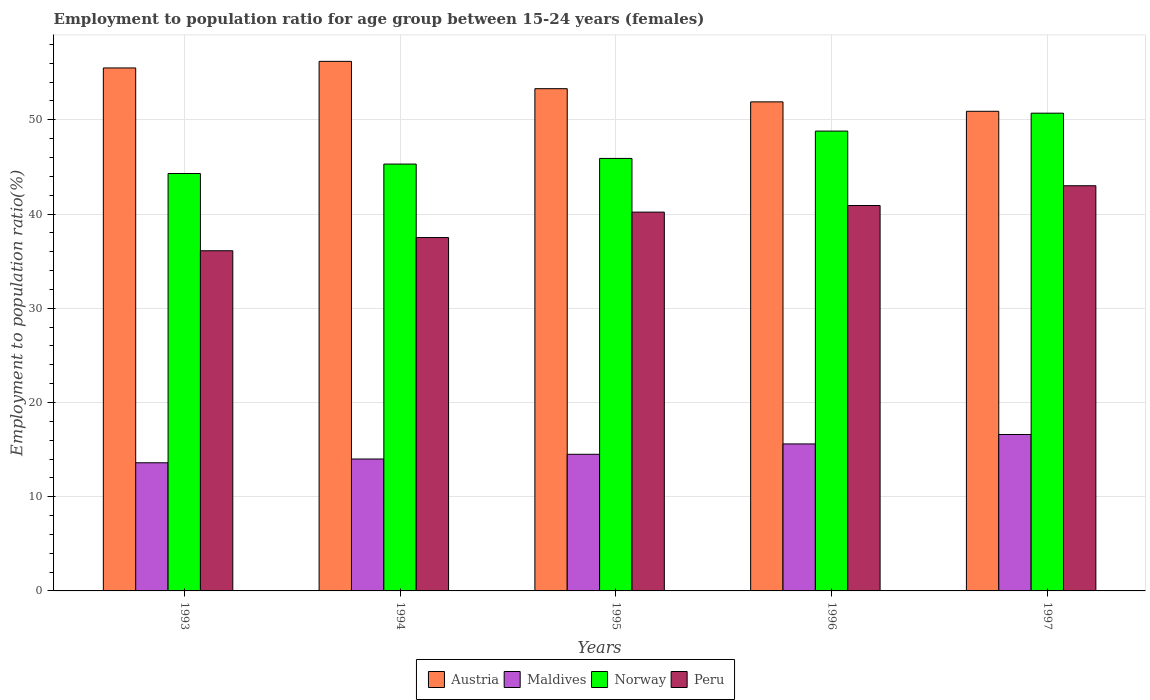Are the number of bars on each tick of the X-axis equal?
Ensure brevity in your answer.  Yes. How many bars are there on the 5th tick from the left?
Ensure brevity in your answer.  4. How many bars are there on the 1st tick from the right?
Offer a very short reply. 4. What is the label of the 2nd group of bars from the left?
Make the answer very short. 1994. In how many cases, is the number of bars for a given year not equal to the number of legend labels?
Your answer should be very brief. 0. What is the employment to population ratio in Maldives in 1996?
Provide a succinct answer. 15.6. Across all years, what is the maximum employment to population ratio in Austria?
Make the answer very short. 56.2. Across all years, what is the minimum employment to population ratio in Norway?
Offer a terse response. 44.3. In which year was the employment to population ratio in Norway maximum?
Offer a terse response. 1997. What is the total employment to population ratio in Austria in the graph?
Give a very brief answer. 267.8. What is the difference between the employment to population ratio in Maldives in 1996 and that in 1997?
Ensure brevity in your answer.  -1. What is the difference between the employment to population ratio in Maldives in 1996 and the employment to population ratio in Austria in 1995?
Provide a succinct answer. -37.7. What is the average employment to population ratio in Norway per year?
Keep it short and to the point. 47. In the year 1994, what is the difference between the employment to population ratio in Norway and employment to population ratio in Maldives?
Ensure brevity in your answer.  31.3. What is the ratio of the employment to population ratio in Norway in 1994 to that in 1995?
Your answer should be very brief. 0.99. Is the employment to population ratio in Norway in 1994 less than that in 1995?
Provide a succinct answer. Yes. Is the difference between the employment to population ratio in Norway in 1993 and 1994 greater than the difference between the employment to population ratio in Maldives in 1993 and 1994?
Offer a very short reply. No. What is the difference between the highest and the second highest employment to population ratio in Norway?
Provide a short and direct response. 1.9. What is the difference between the highest and the lowest employment to population ratio in Maldives?
Your response must be concise. 3. In how many years, is the employment to population ratio in Peru greater than the average employment to population ratio in Peru taken over all years?
Your answer should be compact. 3. Is the sum of the employment to population ratio in Maldives in 1993 and 1995 greater than the maximum employment to population ratio in Peru across all years?
Your answer should be very brief. No. Is it the case that in every year, the sum of the employment to population ratio in Austria and employment to population ratio in Peru is greater than the sum of employment to population ratio in Maldives and employment to population ratio in Norway?
Keep it short and to the point. Yes. Are all the bars in the graph horizontal?
Provide a short and direct response. No. Where does the legend appear in the graph?
Provide a short and direct response. Bottom center. How many legend labels are there?
Provide a succinct answer. 4. How are the legend labels stacked?
Ensure brevity in your answer.  Horizontal. What is the title of the graph?
Make the answer very short. Employment to population ratio for age group between 15-24 years (females). Does "Slovak Republic" appear as one of the legend labels in the graph?
Keep it short and to the point. No. What is the label or title of the X-axis?
Ensure brevity in your answer.  Years. What is the Employment to population ratio(%) of Austria in 1993?
Make the answer very short. 55.5. What is the Employment to population ratio(%) of Maldives in 1993?
Offer a terse response. 13.6. What is the Employment to population ratio(%) in Norway in 1993?
Your answer should be compact. 44.3. What is the Employment to population ratio(%) in Peru in 1993?
Offer a very short reply. 36.1. What is the Employment to population ratio(%) in Austria in 1994?
Ensure brevity in your answer.  56.2. What is the Employment to population ratio(%) of Maldives in 1994?
Keep it short and to the point. 14. What is the Employment to population ratio(%) in Norway in 1994?
Offer a very short reply. 45.3. What is the Employment to population ratio(%) of Peru in 1994?
Make the answer very short. 37.5. What is the Employment to population ratio(%) of Austria in 1995?
Your answer should be compact. 53.3. What is the Employment to population ratio(%) in Maldives in 1995?
Offer a terse response. 14.5. What is the Employment to population ratio(%) in Norway in 1995?
Ensure brevity in your answer.  45.9. What is the Employment to population ratio(%) in Peru in 1995?
Offer a very short reply. 40.2. What is the Employment to population ratio(%) of Austria in 1996?
Make the answer very short. 51.9. What is the Employment to population ratio(%) in Maldives in 1996?
Make the answer very short. 15.6. What is the Employment to population ratio(%) of Norway in 1996?
Offer a terse response. 48.8. What is the Employment to population ratio(%) in Peru in 1996?
Offer a very short reply. 40.9. What is the Employment to population ratio(%) in Austria in 1997?
Ensure brevity in your answer.  50.9. What is the Employment to population ratio(%) in Maldives in 1997?
Your response must be concise. 16.6. What is the Employment to population ratio(%) in Norway in 1997?
Your answer should be very brief. 50.7. Across all years, what is the maximum Employment to population ratio(%) of Austria?
Provide a succinct answer. 56.2. Across all years, what is the maximum Employment to population ratio(%) in Maldives?
Give a very brief answer. 16.6. Across all years, what is the maximum Employment to population ratio(%) in Norway?
Make the answer very short. 50.7. Across all years, what is the minimum Employment to population ratio(%) of Austria?
Your answer should be compact. 50.9. Across all years, what is the minimum Employment to population ratio(%) in Maldives?
Offer a terse response. 13.6. Across all years, what is the minimum Employment to population ratio(%) of Norway?
Offer a terse response. 44.3. Across all years, what is the minimum Employment to population ratio(%) of Peru?
Provide a succinct answer. 36.1. What is the total Employment to population ratio(%) of Austria in the graph?
Make the answer very short. 267.8. What is the total Employment to population ratio(%) in Maldives in the graph?
Offer a very short reply. 74.3. What is the total Employment to population ratio(%) in Norway in the graph?
Provide a succinct answer. 235. What is the total Employment to population ratio(%) in Peru in the graph?
Provide a succinct answer. 197.7. What is the difference between the Employment to population ratio(%) in Austria in 1993 and that in 1994?
Ensure brevity in your answer.  -0.7. What is the difference between the Employment to population ratio(%) of Maldives in 1993 and that in 1994?
Offer a terse response. -0.4. What is the difference between the Employment to population ratio(%) in Norway in 1993 and that in 1994?
Offer a very short reply. -1. What is the difference between the Employment to population ratio(%) of Maldives in 1993 and that in 1995?
Ensure brevity in your answer.  -0.9. What is the difference between the Employment to population ratio(%) in Norway in 1993 and that in 1995?
Your response must be concise. -1.6. What is the difference between the Employment to population ratio(%) of Peru in 1993 and that in 1995?
Offer a very short reply. -4.1. What is the difference between the Employment to population ratio(%) of Austria in 1993 and that in 1996?
Your answer should be compact. 3.6. What is the difference between the Employment to population ratio(%) in Maldives in 1993 and that in 1996?
Provide a succinct answer. -2. What is the difference between the Employment to population ratio(%) of Norway in 1993 and that in 1996?
Keep it short and to the point. -4.5. What is the difference between the Employment to population ratio(%) of Austria in 1993 and that in 1997?
Keep it short and to the point. 4.6. What is the difference between the Employment to population ratio(%) in Maldives in 1993 and that in 1997?
Give a very brief answer. -3. What is the difference between the Employment to population ratio(%) in Peru in 1993 and that in 1997?
Offer a very short reply. -6.9. What is the difference between the Employment to population ratio(%) in Norway in 1994 and that in 1995?
Your answer should be very brief. -0.6. What is the difference between the Employment to population ratio(%) in Peru in 1994 and that in 1995?
Offer a very short reply. -2.7. What is the difference between the Employment to population ratio(%) of Maldives in 1994 and that in 1996?
Your answer should be compact. -1.6. What is the difference between the Employment to population ratio(%) of Maldives in 1994 and that in 1997?
Offer a very short reply. -2.6. What is the difference between the Employment to population ratio(%) of Austria in 1995 and that in 1996?
Give a very brief answer. 1.4. What is the difference between the Employment to population ratio(%) in Norway in 1995 and that in 1996?
Your answer should be compact. -2.9. What is the difference between the Employment to population ratio(%) of Maldives in 1995 and that in 1997?
Your answer should be compact. -2.1. What is the difference between the Employment to population ratio(%) of Norway in 1995 and that in 1997?
Ensure brevity in your answer.  -4.8. What is the difference between the Employment to population ratio(%) in Maldives in 1996 and that in 1997?
Provide a short and direct response. -1. What is the difference between the Employment to population ratio(%) of Peru in 1996 and that in 1997?
Ensure brevity in your answer.  -2.1. What is the difference between the Employment to population ratio(%) in Austria in 1993 and the Employment to population ratio(%) in Maldives in 1994?
Your answer should be very brief. 41.5. What is the difference between the Employment to population ratio(%) in Austria in 1993 and the Employment to population ratio(%) in Norway in 1994?
Provide a succinct answer. 10.2. What is the difference between the Employment to population ratio(%) of Maldives in 1993 and the Employment to population ratio(%) of Norway in 1994?
Provide a succinct answer. -31.7. What is the difference between the Employment to population ratio(%) in Maldives in 1993 and the Employment to population ratio(%) in Peru in 1994?
Keep it short and to the point. -23.9. What is the difference between the Employment to population ratio(%) in Norway in 1993 and the Employment to population ratio(%) in Peru in 1994?
Your answer should be compact. 6.8. What is the difference between the Employment to population ratio(%) of Austria in 1993 and the Employment to population ratio(%) of Maldives in 1995?
Make the answer very short. 41. What is the difference between the Employment to population ratio(%) of Austria in 1993 and the Employment to population ratio(%) of Norway in 1995?
Your answer should be compact. 9.6. What is the difference between the Employment to population ratio(%) of Maldives in 1993 and the Employment to population ratio(%) of Norway in 1995?
Your answer should be very brief. -32.3. What is the difference between the Employment to population ratio(%) in Maldives in 1993 and the Employment to population ratio(%) in Peru in 1995?
Your answer should be compact. -26.6. What is the difference between the Employment to population ratio(%) of Austria in 1993 and the Employment to population ratio(%) of Maldives in 1996?
Offer a very short reply. 39.9. What is the difference between the Employment to population ratio(%) in Austria in 1993 and the Employment to population ratio(%) in Norway in 1996?
Offer a very short reply. 6.7. What is the difference between the Employment to population ratio(%) in Maldives in 1993 and the Employment to population ratio(%) in Norway in 1996?
Make the answer very short. -35.2. What is the difference between the Employment to population ratio(%) in Maldives in 1993 and the Employment to population ratio(%) in Peru in 1996?
Offer a terse response. -27.3. What is the difference between the Employment to population ratio(%) in Norway in 1993 and the Employment to population ratio(%) in Peru in 1996?
Your answer should be very brief. 3.4. What is the difference between the Employment to population ratio(%) of Austria in 1993 and the Employment to population ratio(%) of Maldives in 1997?
Provide a short and direct response. 38.9. What is the difference between the Employment to population ratio(%) in Austria in 1993 and the Employment to population ratio(%) in Norway in 1997?
Your response must be concise. 4.8. What is the difference between the Employment to population ratio(%) of Austria in 1993 and the Employment to population ratio(%) of Peru in 1997?
Your answer should be compact. 12.5. What is the difference between the Employment to population ratio(%) of Maldives in 1993 and the Employment to population ratio(%) of Norway in 1997?
Provide a succinct answer. -37.1. What is the difference between the Employment to population ratio(%) in Maldives in 1993 and the Employment to population ratio(%) in Peru in 1997?
Your answer should be very brief. -29.4. What is the difference between the Employment to population ratio(%) in Norway in 1993 and the Employment to population ratio(%) in Peru in 1997?
Make the answer very short. 1.3. What is the difference between the Employment to population ratio(%) in Austria in 1994 and the Employment to population ratio(%) in Maldives in 1995?
Offer a terse response. 41.7. What is the difference between the Employment to population ratio(%) of Austria in 1994 and the Employment to population ratio(%) of Peru in 1995?
Ensure brevity in your answer.  16. What is the difference between the Employment to population ratio(%) of Maldives in 1994 and the Employment to population ratio(%) of Norway in 1995?
Offer a terse response. -31.9. What is the difference between the Employment to population ratio(%) in Maldives in 1994 and the Employment to population ratio(%) in Peru in 1995?
Keep it short and to the point. -26.2. What is the difference between the Employment to population ratio(%) of Austria in 1994 and the Employment to population ratio(%) of Maldives in 1996?
Make the answer very short. 40.6. What is the difference between the Employment to population ratio(%) of Austria in 1994 and the Employment to population ratio(%) of Norway in 1996?
Ensure brevity in your answer.  7.4. What is the difference between the Employment to population ratio(%) of Maldives in 1994 and the Employment to population ratio(%) of Norway in 1996?
Offer a very short reply. -34.8. What is the difference between the Employment to population ratio(%) of Maldives in 1994 and the Employment to population ratio(%) of Peru in 1996?
Your answer should be very brief. -26.9. What is the difference between the Employment to population ratio(%) in Norway in 1994 and the Employment to population ratio(%) in Peru in 1996?
Ensure brevity in your answer.  4.4. What is the difference between the Employment to population ratio(%) in Austria in 1994 and the Employment to population ratio(%) in Maldives in 1997?
Your answer should be compact. 39.6. What is the difference between the Employment to population ratio(%) in Maldives in 1994 and the Employment to population ratio(%) in Norway in 1997?
Provide a short and direct response. -36.7. What is the difference between the Employment to population ratio(%) of Norway in 1994 and the Employment to population ratio(%) of Peru in 1997?
Offer a terse response. 2.3. What is the difference between the Employment to population ratio(%) of Austria in 1995 and the Employment to population ratio(%) of Maldives in 1996?
Provide a succinct answer. 37.7. What is the difference between the Employment to population ratio(%) in Austria in 1995 and the Employment to population ratio(%) in Norway in 1996?
Ensure brevity in your answer.  4.5. What is the difference between the Employment to population ratio(%) of Austria in 1995 and the Employment to population ratio(%) of Peru in 1996?
Your response must be concise. 12.4. What is the difference between the Employment to population ratio(%) of Maldives in 1995 and the Employment to population ratio(%) of Norway in 1996?
Offer a very short reply. -34.3. What is the difference between the Employment to population ratio(%) in Maldives in 1995 and the Employment to population ratio(%) in Peru in 1996?
Provide a short and direct response. -26.4. What is the difference between the Employment to population ratio(%) in Austria in 1995 and the Employment to population ratio(%) in Maldives in 1997?
Make the answer very short. 36.7. What is the difference between the Employment to population ratio(%) of Austria in 1995 and the Employment to population ratio(%) of Norway in 1997?
Your response must be concise. 2.6. What is the difference between the Employment to population ratio(%) of Maldives in 1995 and the Employment to population ratio(%) of Norway in 1997?
Offer a terse response. -36.2. What is the difference between the Employment to population ratio(%) of Maldives in 1995 and the Employment to population ratio(%) of Peru in 1997?
Your response must be concise. -28.5. What is the difference between the Employment to population ratio(%) of Norway in 1995 and the Employment to population ratio(%) of Peru in 1997?
Your answer should be very brief. 2.9. What is the difference between the Employment to population ratio(%) of Austria in 1996 and the Employment to population ratio(%) of Maldives in 1997?
Make the answer very short. 35.3. What is the difference between the Employment to population ratio(%) in Austria in 1996 and the Employment to population ratio(%) in Peru in 1997?
Your response must be concise. 8.9. What is the difference between the Employment to population ratio(%) of Maldives in 1996 and the Employment to population ratio(%) of Norway in 1997?
Offer a very short reply. -35.1. What is the difference between the Employment to population ratio(%) of Maldives in 1996 and the Employment to population ratio(%) of Peru in 1997?
Your answer should be very brief. -27.4. What is the average Employment to population ratio(%) in Austria per year?
Provide a succinct answer. 53.56. What is the average Employment to population ratio(%) of Maldives per year?
Give a very brief answer. 14.86. What is the average Employment to population ratio(%) of Peru per year?
Offer a terse response. 39.54. In the year 1993, what is the difference between the Employment to population ratio(%) of Austria and Employment to population ratio(%) of Maldives?
Provide a succinct answer. 41.9. In the year 1993, what is the difference between the Employment to population ratio(%) of Austria and Employment to population ratio(%) of Peru?
Your answer should be compact. 19.4. In the year 1993, what is the difference between the Employment to population ratio(%) of Maldives and Employment to population ratio(%) of Norway?
Give a very brief answer. -30.7. In the year 1993, what is the difference between the Employment to population ratio(%) of Maldives and Employment to population ratio(%) of Peru?
Offer a very short reply. -22.5. In the year 1994, what is the difference between the Employment to population ratio(%) of Austria and Employment to population ratio(%) of Maldives?
Your answer should be very brief. 42.2. In the year 1994, what is the difference between the Employment to population ratio(%) of Maldives and Employment to population ratio(%) of Norway?
Your response must be concise. -31.3. In the year 1994, what is the difference between the Employment to population ratio(%) of Maldives and Employment to population ratio(%) of Peru?
Ensure brevity in your answer.  -23.5. In the year 1995, what is the difference between the Employment to population ratio(%) of Austria and Employment to population ratio(%) of Maldives?
Offer a terse response. 38.8. In the year 1995, what is the difference between the Employment to population ratio(%) in Maldives and Employment to population ratio(%) in Norway?
Offer a very short reply. -31.4. In the year 1995, what is the difference between the Employment to population ratio(%) in Maldives and Employment to population ratio(%) in Peru?
Offer a very short reply. -25.7. In the year 1995, what is the difference between the Employment to population ratio(%) in Norway and Employment to population ratio(%) in Peru?
Give a very brief answer. 5.7. In the year 1996, what is the difference between the Employment to population ratio(%) of Austria and Employment to population ratio(%) of Maldives?
Your answer should be compact. 36.3. In the year 1996, what is the difference between the Employment to population ratio(%) in Maldives and Employment to population ratio(%) in Norway?
Keep it short and to the point. -33.2. In the year 1996, what is the difference between the Employment to population ratio(%) in Maldives and Employment to population ratio(%) in Peru?
Make the answer very short. -25.3. In the year 1996, what is the difference between the Employment to population ratio(%) in Norway and Employment to population ratio(%) in Peru?
Provide a short and direct response. 7.9. In the year 1997, what is the difference between the Employment to population ratio(%) in Austria and Employment to population ratio(%) in Maldives?
Keep it short and to the point. 34.3. In the year 1997, what is the difference between the Employment to population ratio(%) of Austria and Employment to population ratio(%) of Norway?
Make the answer very short. 0.2. In the year 1997, what is the difference between the Employment to population ratio(%) of Maldives and Employment to population ratio(%) of Norway?
Offer a terse response. -34.1. In the year 1997, what is the difference between the Employment to population ratio(%) in Maldives and Employment to population ratio(%) in Peru?
Make the answer very short. -26.4. In the year 1997, what is the difference between the Employment to population ratio(%) of Norway and Employment to population ratio(%) of Peru?
Give a very brief answer. 7.7. What is the ratio of the Employment to population ratio(%) of Austria in 1993 to that in 1994?
Ensure brevity in your answer.  0.99. What is the ratio of the Employment to population ratio(%) of Maldives in 1993 to that in 1994?
Your answer should be compact. 0.97. What is the ratio of the Employment to population ratio(%) of Norway in 1993 to that in 1994?
Provide a succinct answer. 0.98. What is the ratio of the Employment to population ratio(%) in Peru in 1993 to that in 1994?
Provide a short and direct response. 0.96. What is the ratio of the Employment to population ratio(%) in Austria in 1993 to that in 1995?
Provide a short and direct response. 1.04. What is the ratio of the Employment to population ratio(%) in Maldives in 1993 to that in 1995?
Your response must be concise. 0.94. What is the ratio of the Employment to population ratio(%) of Norway in 1993 to that in 1995?
Ensure brevity in your answer.  0.97. What is the ratio of the Employment to population ratio(%) in Peru in 1993 to that in 1995?
Your response must be concise. 0.9. What is the ratio of the Employment to population ratio(%) of Austria in 1993 to that in 1996?
Your answer should be compact. 1.07. What is the ratio of the Employment to population ratio(%) in Maldives in 1993 to that in 1996?
Offer a terse response. 0.87. What is the ratio of the Employment to population ratio(%) of Norway in 1993 to that in 1996?
Offer a terse response. 0.91. What is the ratio of the Employment to population ratio(%) in Peru in 1993 to that in 1996?
Provide a short and direct response. 0.88. What is the ratio of the Employment to population ratio(%) of Austria in 1993 to that in 1997?
Make the answer very short. 1.09. What is the ratio of the Employment to population ratio(%) in Maldives in 1993 to that in 1997?
Offer a terse response. 0.82. What is the ratio of the Employment to population ratio(%) of Norway in 1993 to that in 1997?
Give a very brief answer. 0.87. What is the ratio of the Employment to population ratio(%) of Peru in 1993 to that in 1997?
Make the answer very short. 0.84. What is the ratio of the Employment to population ratio(%) in Austria in 1994 to that in 1995?
Offer a terse response. 1.05. What is the ratio of the Employment to population ratio(%) in Maldives in 1994 to that in 1995?
Ensure brevity in your answer.  0.97. What is the ratio of the Employment to population ratio(%) in Norway in 1994 to that in 1995?
Keep it short and to the point. 0.99. What is the ratio of the Employment to population ratio(%) in Peru in 1994 to that in 1995?
Make the answer very short. 0.93. What is the ratio of the Employment to population ratio(%) in Austria in 1994 to that in 1996?
Ensure brevity in your answer.  1.08. What is the ratio of the Employment to population ratio(%) of Maldives in 1994 to that in 1996?
Give a very brief answer. 0.9. What is the ratio of the Employment to population ratio(%) in Norway in 1994 to that in 1996?
Your answer should be compact. 0.93. What is the ratio of the Employment to population ratio(%) of Peru in 1994 to that in 1996?
Keep it short and to the point. 0.92. What is the ratio of the Employment to population ratio(%) in Austria in 1994 to that in 1997?
Ensure brevity in your answer.  1.1. What is the ratio of the Employment to population ratio(%) in Maldives in 1994 to that in 1997?
Your answer should be very brief. 0.84. What is the ratio of the Employment to population ratio(%) in Norway in 1994 to that in 1997?
Keep it short and to the point. 0.89. What is the ratio of the Employment to population ratio(%) of Peru in 1994 to that in 1997?
Provide a succinct answer. 0.87. What is the ratio of the Employment to population ratio(%) in Maldives in 1995 to that in 1996?
Provide a short and direct response. 0.93. What is the ratio of the Employment to population ratio(%) of Norway in 1995 to that in 1996?
Your response must be concise. 0.94. What is the ratio of the Employment to population ratio(%) in Peru in 1995 to that in 1996?
Provide a short and direct response. 0.98. What is the ratio of the Employment to population ratio(%) in Austria in 1995 to that in 1997?
Provide a short and direct response. 1.05. What is the ratio of the Employment to population ratio(%) in Maldives in 1995 to that in 1997?
Keep it short and to the point. 0.87. What is the ratio of the Employment to population ratio(%) in Norway in 1995 to that in 1997?
Keep it short and to the point. 0.91. What is the ratio of the Employment to population ratio(%) of Peru in 1995 to that in 1997?
Keep it short and to the point. 0.93. What is the ratio of the Employment to population ratio(%) in Austria in 1996 to that in 1997?
Offer a very short reply. 1.02. What is the ratio of the Employment to population ratio(%) in Maldives in 1996 to that in 1997?
Your answer should be compact. 0.94. What is the ratio of the Employment to population ratio(%) in Norway in 1996 to that in 1997?
Your answer should be compact. 0.96. What is the ratio of the Employment to population ratio(%) of Peru in 1996 to that in 1997?
Your answer should be compact. 0.95. What is the difference between the highest and the second highest Employment to population ratio(%) in Norway?
Provide a succinct answer. 1.9. What is the difference between the highest and the second highest Employment to population ratio(%) of Peru?
Offer a very short reply. 2.1. What is the difference between the highest and the lowest Employment to population ratio(%) in Maldives?
Provide a succinct answer. 3. What is the difference between the highest and the lowest Employment to population ratio(%) of Peru?
Offer a terse response. 6.9. 